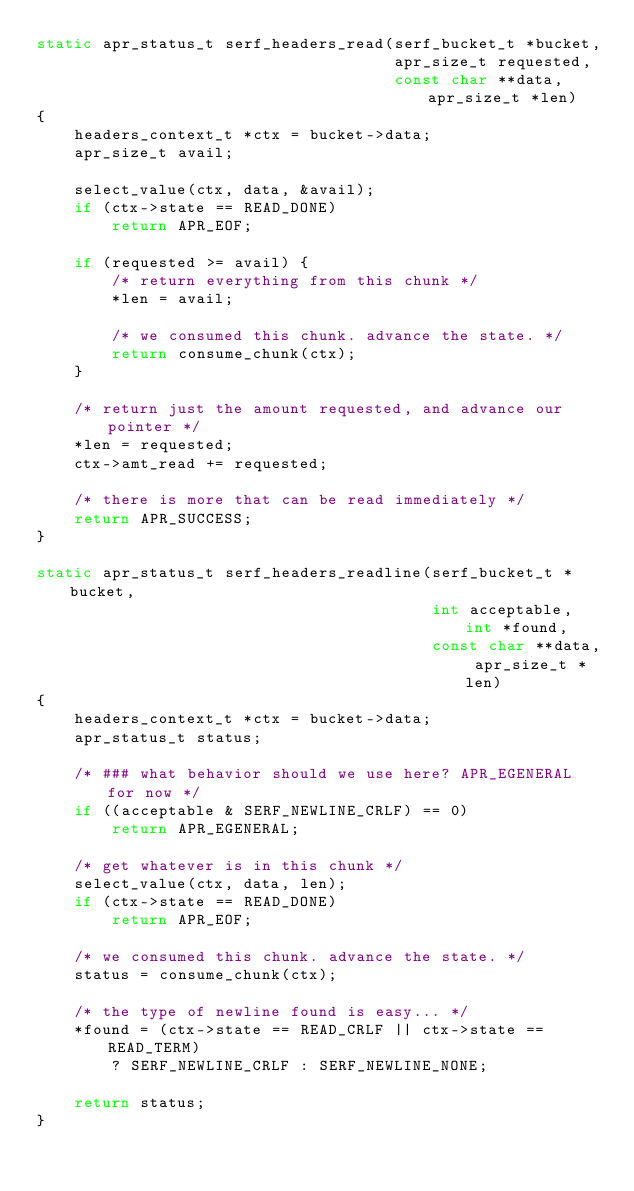Convert code to text. <code><loc_0><loc_0><loc_500><loc_500><_C_>static apr_status_t serf_headers_read(serf_bucket_t *bucket,
                                      apr_size_t requested,
                                      const char **data, apr_size_t *len)
{
    headers_context_t *ctx = bucket->data;
    apr_size_t avail;

    select_value(ctx, data, &avail);
    if (ctx->state == READ_DONE)
        return APR_EOF;

    if (requested >= avail) {
        /* return everything from this chunk */
        *len = avail;
        
        /* we consumed this chunk. advance the state. */
        return consume_chunk(ctx);
    }

    /* return just the amount requested, and advance our pointer */
    *len = requested;
    ctx->amt_read += requested;

    /* there is more that can be read immediately */
    return APR_SUCCESS;
}

static apr_status_t serf_headers_readline(serf_bucket_t *bucket,
                                          int acceptable, int *found,
                                          const char **data, apr_size_t *len)
{
    headers_context_t *ctx = bucket->data;
    apr_status_t status;

    /* ### what behavior should we use here? APR_EGENERAL for now */
    if ((acceptable & SERF_NEWLINE_CRLF) == 0)
        return APR_EGENERAL;

    /* get whatever is in this chunk */
    select_value(ctx, data, len);
    if (ctx->state == READ_DONE)
        return APR_EOF;

    /* we consumed this chunk. advance the state. */
    status = consume_chunk(ctx);

    /* the type of newline found is easy... */
    *found = (ctx->state == READ_CRLF || ctx->state == READ_TERM)
        ? SERF_NEWLINE_CRLF : SERF_NEWLINE_NONE;

    return status;
}
</code> 